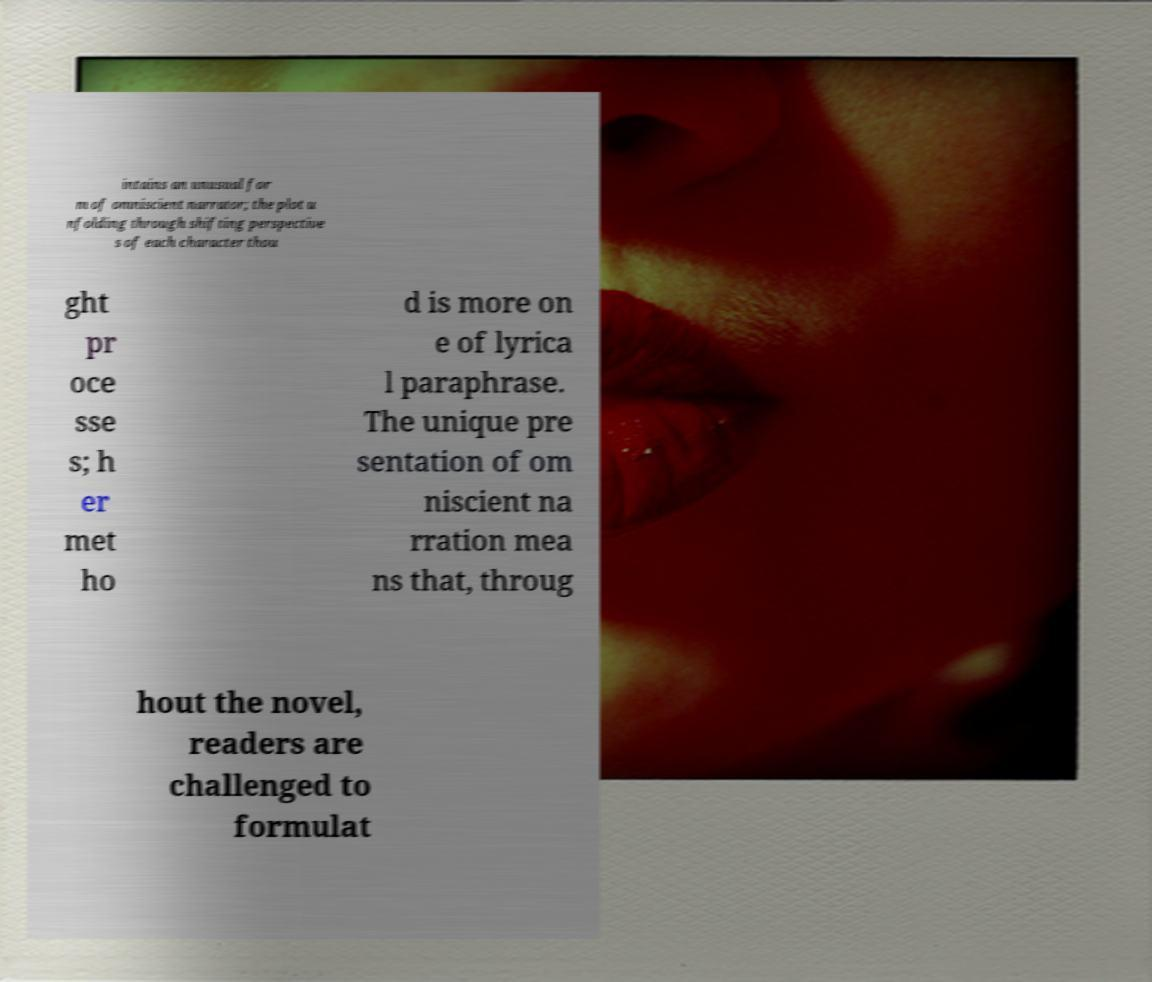Please read and relay the text visible in this image. What does it say? intains an unusual for m of omniscient narrator; the plot u nfolding through shifting perspective s of each character thou ght pr oce sse s; h er met ho d is more on e of lyrica l paraphrase. The unique pre sentation of om niscient na rration mea ns that, throug hout the novel, readers are challenged to formulat 